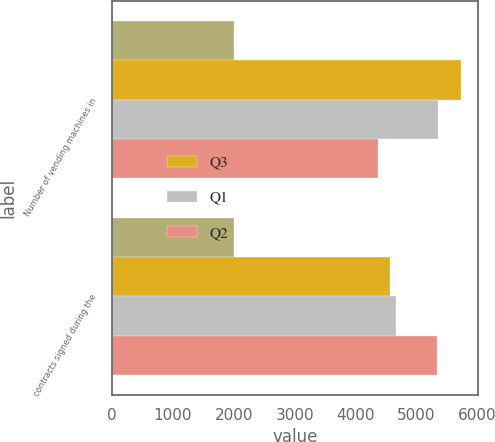<chart> <loc_0><loc_0><loc_500><loc_500><stacked_bar_chart><ecel><fcel>Number of vending machines in<fcel>contracts signed during the<nl><fcel>nan<fcel>2013<fcel>2012<nl><fcel>Q3<fcel>5728<fcel>4568<nl><fcel>Q1<fcel>5357<fcel>4669<nl><fcel>Q2<fcel>4372<fcel>5334<nl></chart> 